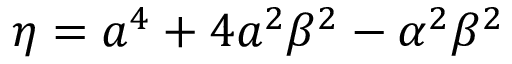<formula> <loc_0><loc_0><loc_500><loc_500>\eta = a ^ { 4 } + 4 a ^ { 2 } \beta ^ { 2 } - \alpha ^ { 2 } \beta ^ { 2 }</formula> 